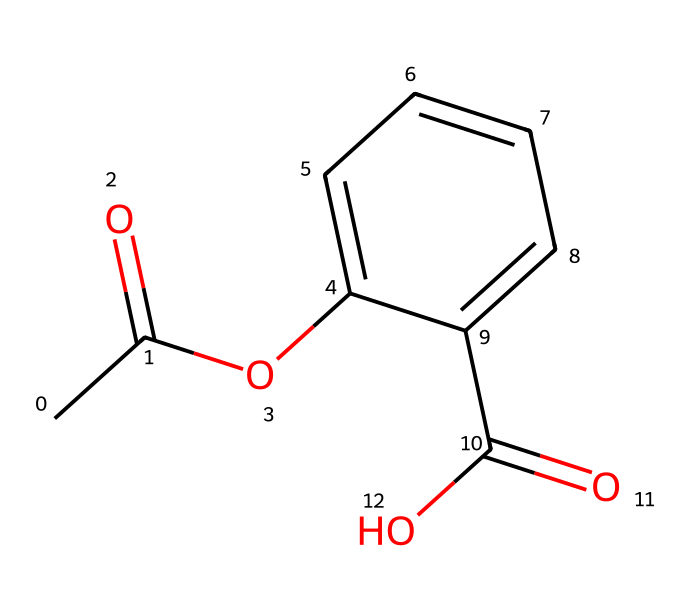What is the name of this chemical? The SMILES representation provided corresponds to aspirin, which is the common name for acetylsalicylic acid. It is often used for pain relief.
Answer: aspirin How many carbon atoms are present in this structure? To find the number of carbon atoms, one can count each carbon (C) in the SMILES representation. There are 9 carbon atoms in the structure of aspirin.
Answer: 9 What type of functional groups are present in this chemical? In the given SMILES, aspirin contains an ester functional group (CC(=O)O) and a carboxylic acid functional group (C(=O)O), which can be identified by looking at the specific patterns in the structure.
Answer: ester and carboxylic acid How many rings are in the structure of this chemical? By examining the structure denoted by the SMILES, there is one ring present, which corresponds to the aromatic part of the aspirin molecule.
Answer: 1 Which bond type is represented by “C(=O)” in the molecule? The “C(=O)” represents a carbonyl group, which indicates a double bond between carbon (C) and oxygen (O). This type of bond is significant in many functional groups, including esters and acids.
Answer: double bond What is the degree of unsaturation in this molecule? The degree of unsaturation can be calculated by analyzing the structure for rings and multiple bonds. Each ring contributes one degree of unsaturation, and each double bond contributes one. Aspiring has a degree of unsaturation of 4.
Answer: 4 What part of the molecule provides its pain-relieving effect? The presence of the acetyl (ester) group is primarily responsible for aspirin's pain-relieving effect due to its mechanism of action in inhibiting certain enzymes (COX).
Answer: acetyl group 